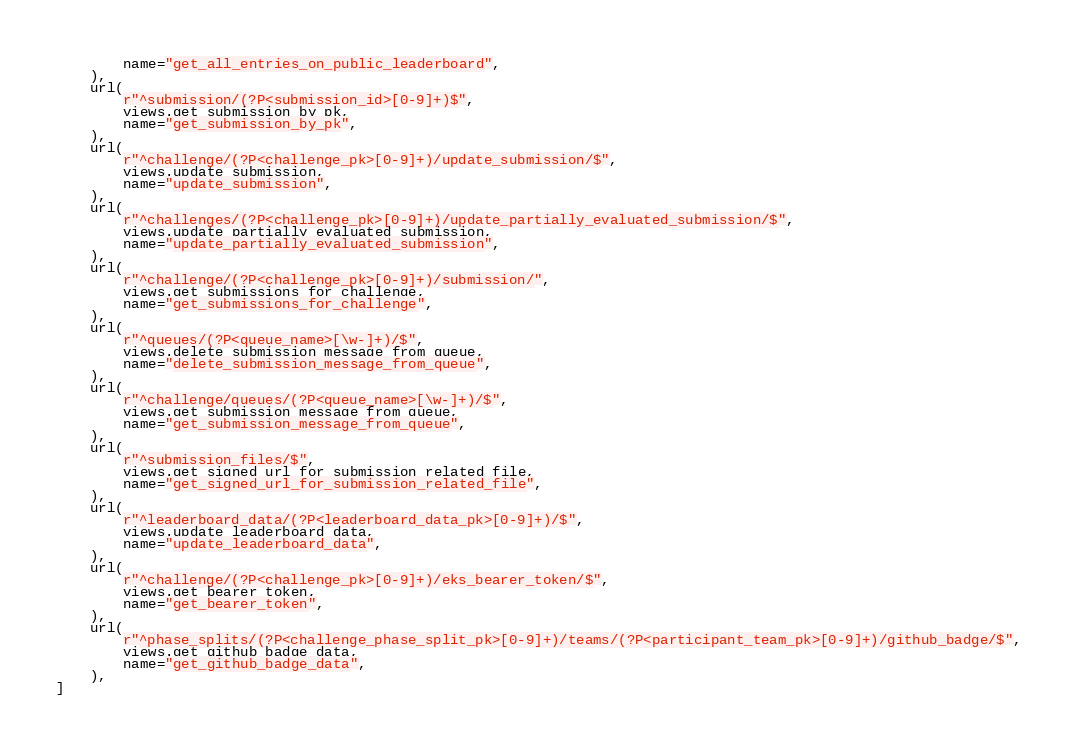<code> <loc_0><loc_0><loc_500><loc_500><_Python_>        name="get_all_entries_on_public_leaderboard",
    ),
    url(
        r"^submission/(?P<submission_id>[0-9]+)$",
        views.get_submission_by_pk,
        name="get_submission_by_pk",
    ),
    url(
        r"^challenge/(?P<challenge_pk>[0-9]+)/update_submission/$",
        views.update_submission,
        name="update_submission",
    ),
    url(
        r"^challenges/(?P<challenge_pk>[0-9]+)/update_partially_evaluated_submission/$",
        views.update_partially_evaluated_submission,
        name="update_partially_evaluated_submission",
    ),
    url(
        r"^challenge/(?P<challenge_pk>[0-9]+)/submission/",
        views.get_submissions_for_challenge,
        name="get_submissions_for_challenge",
    ),
    url(
        r"^queues/(?P<queue_name>[\w-]+)/$",
        views.delete_submission_message_from_queue,
        name="delete_submission_message_from_queue",
    ),
    url(
        r"^challenge/queues/(?P<queue_name>[\w-]+)/$",
        views.get_submission_message_from_queue,
        name="get_submission_message_from_queue",
    ),
    url(
        r"^submission_files/$",
        views.get_signed_url_for_submission_related_file,
        name="get_signed_url_for_submission_related_file",
    ),
    url(
        r"^leaderboard_data/(?P<leaderboard_data_pk>[0-9]+)/$",
        views.update_leaderboard_data,
        name="update_leaderboard_data",
    ),
    url(
        r"^challenge/(?P<challenge_pk>[0-9]+)/eks_bearer_token/$",
        views.get_bearer_token,
        name="get_bearer_token",
    ),
    url(
        r"^phase_splits/(?P<challenge_phase_split_pk>[0-9]+)/teams/(?P<participant_team_pk>[0-9]+)/github_badge/$",
        views.get_github_badge_data,
        name="get_github_badge_data",
    ),
]
</code> 